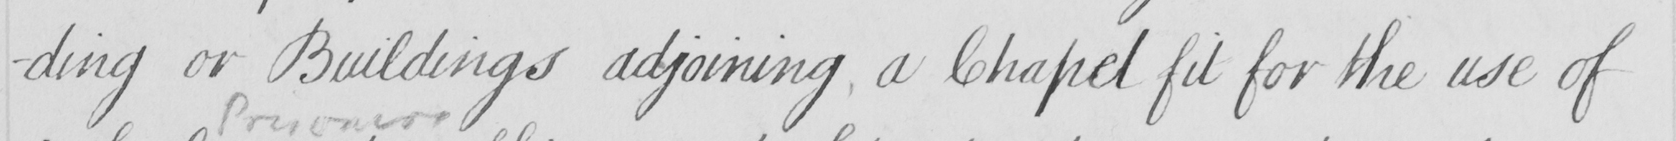What text is written in this handwritten line? -ding or Buildings adjoining , a Chapel fit for the use of 